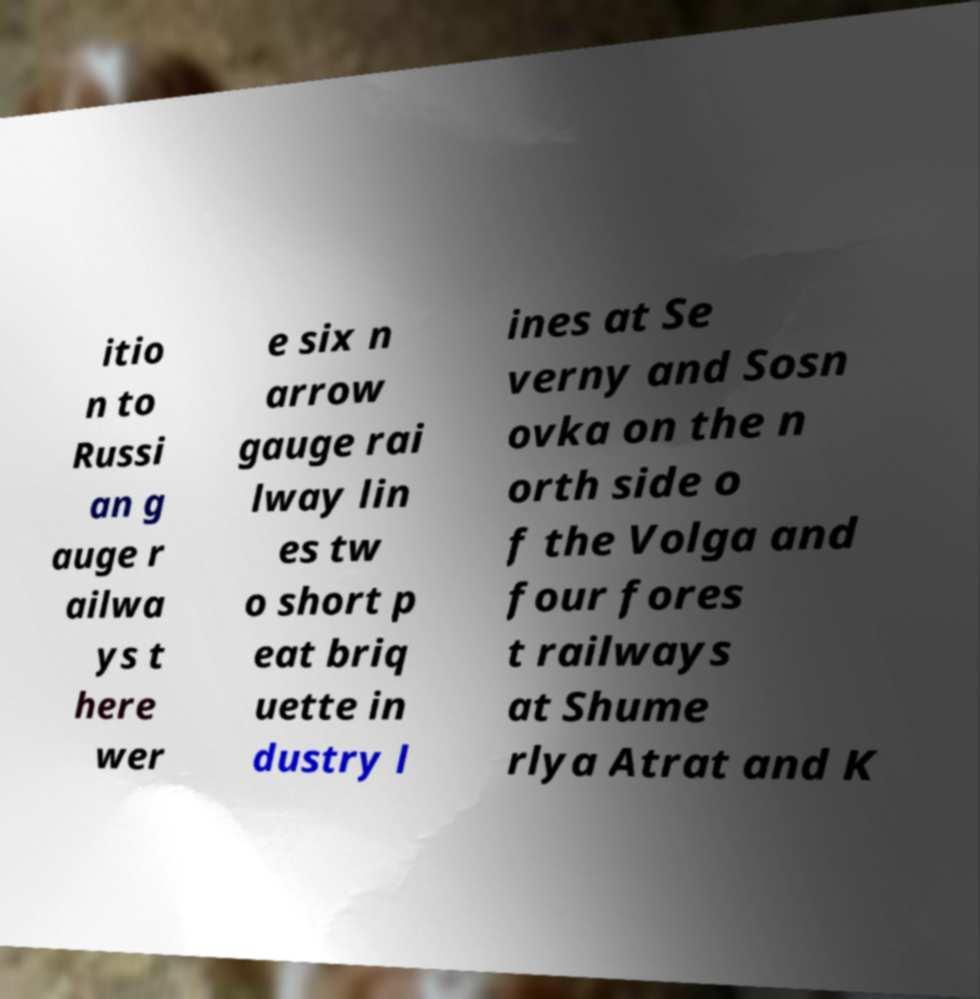Can you accurately transcribe the text from the provided image for me? itio n to Russi an g auge r ailwa ys t here wer e six n arrow gauge rai lway lin es tw o short p eat briq uette in dustry l ines at Se verny and Sosn ovka on the n orth side o f the Volga and four fores t railways at Shume rlya Atrat and K 